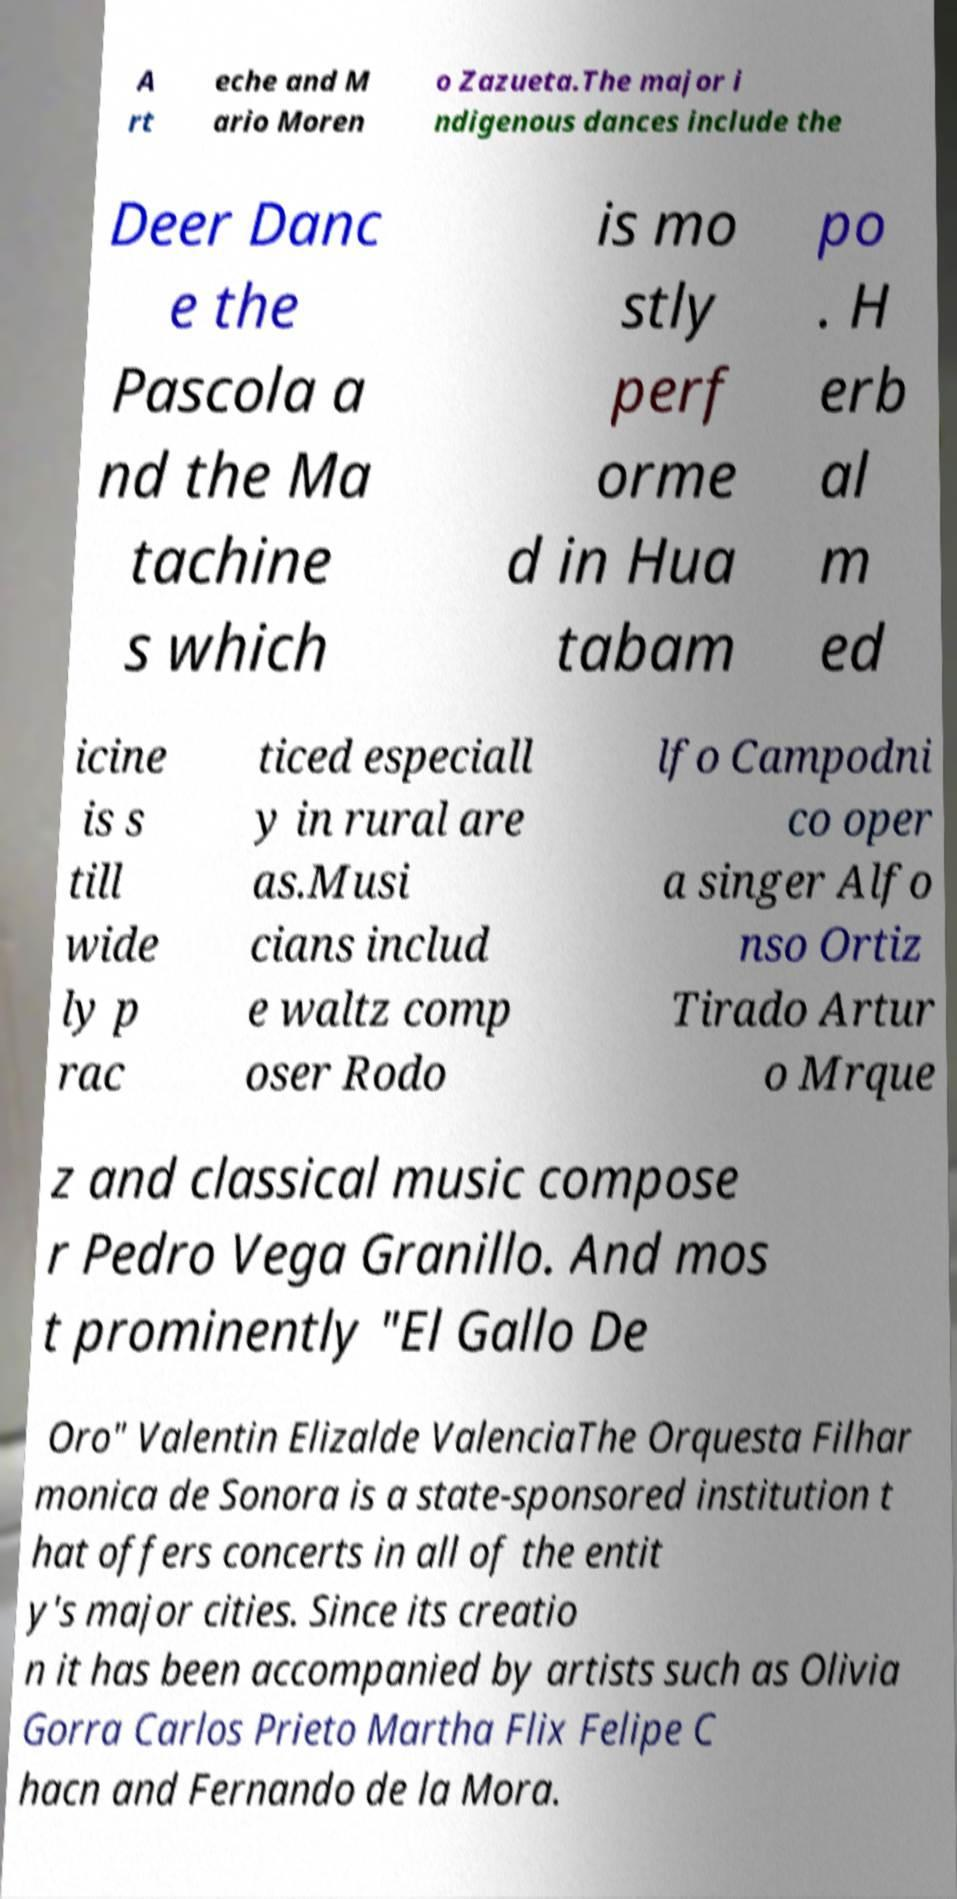What messages or text are displayed in this image? I need them in a readable, typed format. A rt eche and M ario Moren o Zazueta.The major i ndigenous dances include the Deer Danc e the Pascola a nd the Ma tachine s which is mo stly perf orme d in Hua tabam po . H erb al m ed icine is s till wide ly p rac ticed especiall y in rural are as.Musi cians includ e waltz comp oser Rodo lfo Campodni co oper a singer Alfo nso Ortiz Tirado Artur o Mrque z and classical music compose r Pedro Vega Granillo. And mos t prominently "El Gallo De Oro" Valentin Elizalde ValenciaThe Orquesta Filhar monica de Sonora is a state-sponsored institution t hat offers concerts in all of the entit y's major cities. Since its creatio n it has been accompanied by artists such as Olivia Gorra Carlos Prieto Martha Flix Felipe C hacn and Fernando de la Mora. 